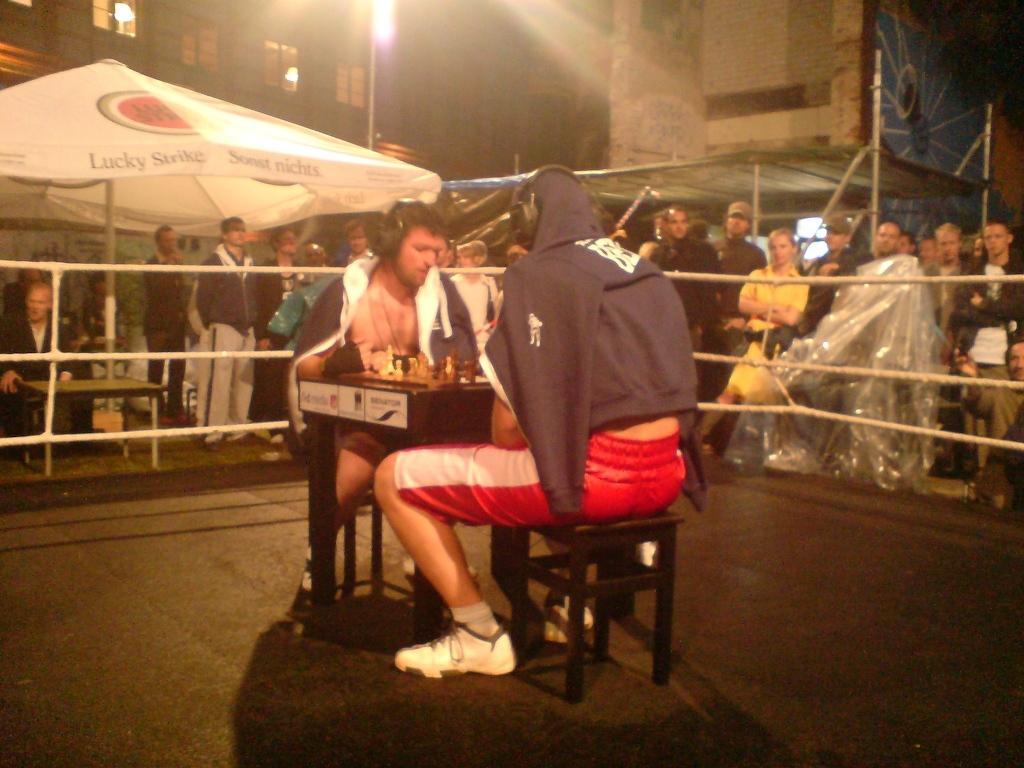Can you describe this image briefly? There are two people sitting on the stool and playing the chess. This looks like a boxing ring. There are groups of people standing. I think this is a patio umbrella. Here is a person sitting. These are the buildings with windows. 